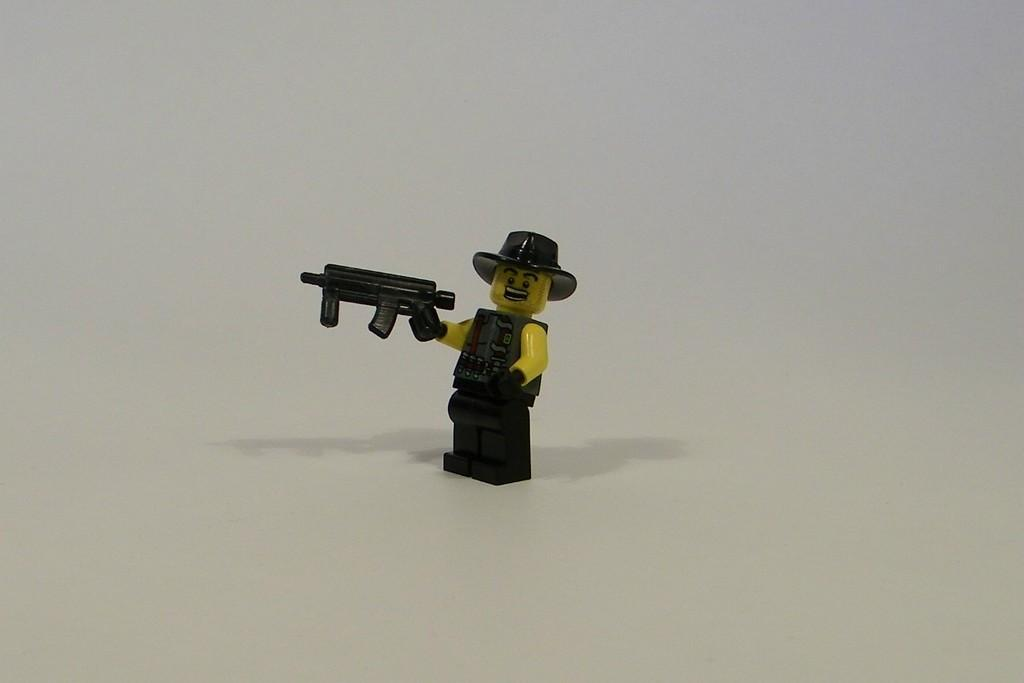What type of object is in the image? There is a toy of a person in the image. What is the toy person wearing? The toy person is wearing clothes and a hat. What is the toy person holding in their hand? The toy person is holding a rifle in their hand. What is the toy person's reaction to the love they feel in the image? There is no indication of love or any emotional reaction in the image; it only shows a toy person holding a rifle. 